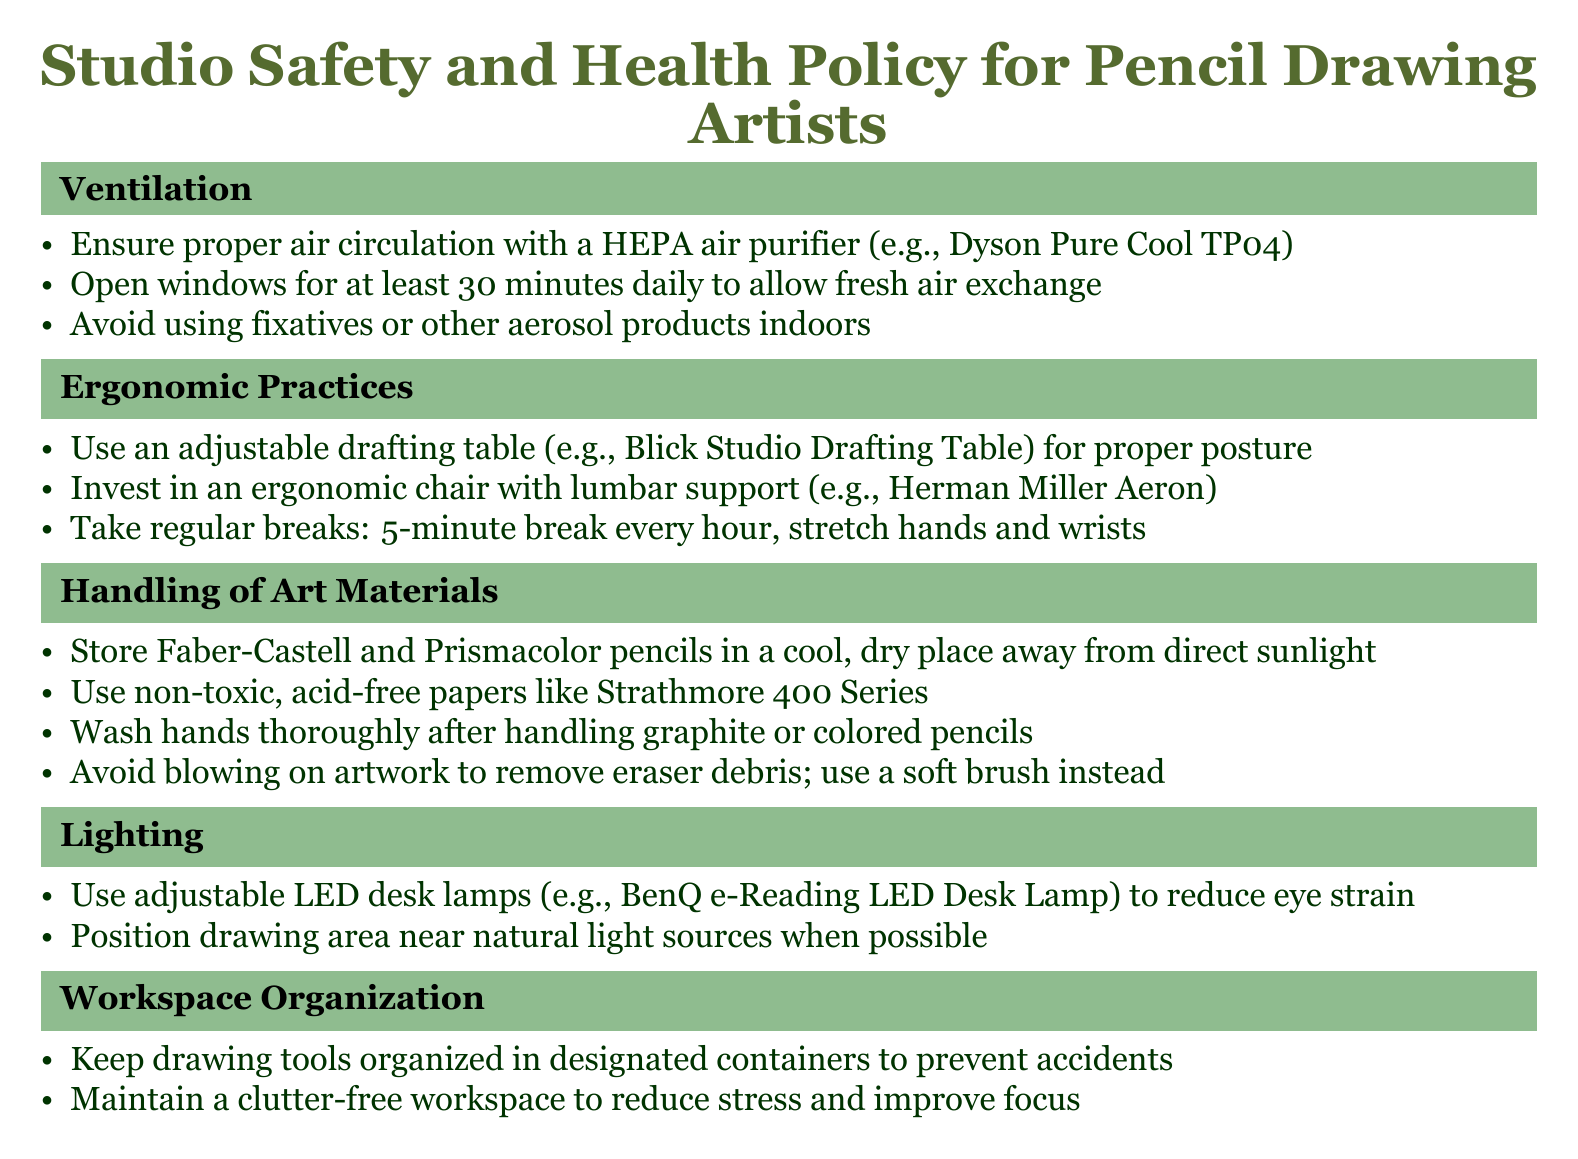What is the recommended air purifier model? The document suggests using a HEPA air purifier, specifically the Dyson Pure Cool TP04.
Answer: Dyson Pure Cool TP04 How often should windows be opened for ventilation? The document states that windows should be opened for at least 30 minutes daily to allow fresh air exchange.
Answer: 30 minutes daily What type of chair is recommended for ergonomic practices? The recommended ergonomic chair in the document is the Herman Miller Aeron.
Answer: Herman Miller Aeron What is the maximum break time recommended every hour? The document recommends a 5-minute break every hour for stretching hands and wrists.
Answer: 5 minutes Which type of paper should be used for handling art materials? The document recommends using non-toxic, acid-free papers like Strathmore 400 Series.
Answer: Strathmore 400 Series What should be avoided instead of blowing on artwork? The document advises using a soft brush instead of blowing on artwork to remove eraser debris.
Answer: Soft brush How should drawing tools be organized? The document specifies that drawing tools should be kept organized in designated containers.
Answer: Designated containers What type of desk lamps is suggested for lighting? The recommended type of desk lamp in the document is adjustable LED desk lamps, specifically the BenQ e-Reading LED Desk Lamp.
Answer: BenQ e-Reading LED Desk Lamp 